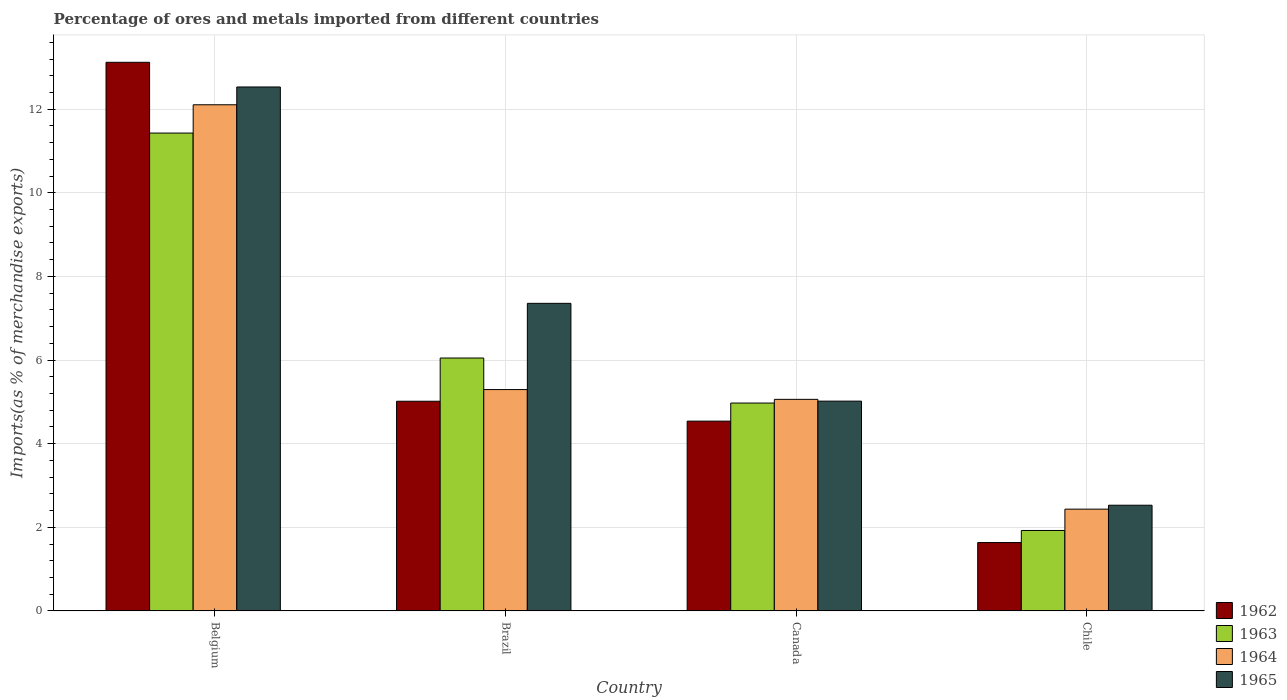How many different coloured bars are there?
Ensure brevity in your answer.  4. How many groups of bars are there?
Provide a succinct answer. 4. Are the number of bars per tick equal to the number of legend labels?
Your response must be concise. Yes. How many bars are there on the 2nd tick from the left?
Offer a very short reply. 4. How many bars are there on the 4th tick from the right?
Offer a very short reply. 4. In how many cases, is the number of bars for a given country not equal to the number of legend labels?
Your answer should be compact. 0. What is the percentage of imports to different countries in 1965 in Brazil?
Provide a succinct answer. 7.36. Across all countries, what is the maximum percentage of imports to different countries in 1965?
Give a very brief answer. 12.53. Across all countries, what is the minimum percentage of imports to different countries in 1965?
Make the answer very short. 2.53. In which country was the percentage of imports to different countries in 1962 maximum?
Provide a succinct answer. Belgium. In which country was the percentage of imports to different countries in 1963 minimum?
Make the answer very short. Chile. What is the total percentage of imports to different countries in 1965 in the graph?
Offer a terse response. 27.43. What is the difference between the percentage of imports to different countries in 1964 in Canada and that in Chile?
Keep it short and to the point. 2.63. What is the difference between the percentage of imports to different countries in 1965 in Belgium and the percentage of imports to different countries in 1963 in Brazil?
Provide a short and direct response. 6.48. What is the average percentage of imports to different countries in 1964 per country?
Offer a very short reply. 6.22. What is the difference between the percentage of imports to different countries of/in 1963 and percentage of imports to different countries of/in 1962 in Chile?
Your answer should be compact. 0.29. What is the ratio of the percentage of imports to different countries in 1962 in Brazil to that in Canada?
Make the answer very short. 1.1. Is the percentage of imports to different countries in 1964 in Belgium less than that in Brazil?
Your answer should be very brief. No. What is the difference between the highest and the second highest percentage of imports to different countries in 1965?
Keep it short and to the point. 7.51. What is the difference between the highest and the lowest percentage of imports to different countries in 1964?
Your response must be concise. 9.67. What does the 4th bar from the left in Brazil represents?
Give a very brief answer. 1965. What does the 1st bar from the right in Brazil represents?
Ensure brevity in your answer.  1965. How many bars are there?
Offer a terse response. 16. Are all the bars in the graph horizontal?
Provide a succinct answer. No. How many countries are there in the graph?
Give a very brief answer. 4. Does the graph contain grids?
Provide a short and direct response. Yes. What is the title of the graph?
Give a very brief answer. Percentage of ores and metals imported from different countries. What is the label or title of the X-axis?
Offer a very short reply. Country. What is the label or title of the Y-axis?
Provide a short and direct response. Imports(as % of merchandise exports). What is the Imports(as % of merchandise exports) of 1962 in Belgium?
Ensure brevity in your answer.  13.12. What is the Imports(as % of merchandise exports) in 1963 in Belgium?
Your answer should be very brief. 11.43. What is the Imports(as % of merchandise exports) in 1964 in Belgium?
Your response must be concise. 12.11. What is the Imports(as % of merchandise exports) of 1965 in Belgium?
Provide a succinct answer. 12.53. What is the Imports(as % of merchandise exports) of 1962 in Brazil?
Keep it short and to the point. 5.01. What is the Imports(as % of merchandise exports) in 1963 in Brazil?
Your response must be concise. 6.05. What is the Imports(as % of merchandise exports) in 1964 in Brazil?
Make the answer very short. 5.29. What is the Imports(as % of merchandise exports) of 1965 in Brazil?
Ensure brevity in your answer.  7.36. What is the Imports(as % of merchandise exports) of 1962 in Canada?
Ensure brevity in your answer.  4.54. What is the Imports(as % of merchandise exports) in 1963 in Canada?
Make the answer very short. 4.97. What is the Imports(as % of merchandise exports) of 1964 in Canada?
Give a very brief answer. 5.06. What is the Imports(as % of merchandise exports) of 1965 in Canada?
Make the answer very short. 5.02. What is the Imports(as % of merchandise exports) of 1962 in Chile?
Offer a very short reply. 1.63. What is the Imports(as % of merchandise exports) in 1963 in Chile?
Give a very brief answer. 1.92. What is the Imports(as % of merchandise exports) in 1964 in Chile?
Your response must be concise. 2.43. What is the Imports(as % of merchandise exports) of 1965 in Chile?
Give a very brief answer. 2.53. Across all countries, what is the maximum Imports(as % of merchandise exports) in 1962?
Your answer should be very brief. 13.12. Across all countries, what is the maximum Imports(as % of merchandise exports) in 1963?
Offer a very short reply. 11.43. Across all countries, what is the maximum Imports(as % of merchandise exports) in 1964?
Give a very brief answer. 12.11. Across all countries, what is the maximum Imports(as % of merchandise exports) of 1965?
Ensure brevity in your answer.  12.53. Across all countries, what is the minimum Imports(as % of merchandise exports) of 1962?
Your answer should be very brief. 1.63. Across all countries, what is the minimum Imports(as % of merchandise exports) in 1963?
Make the answer very short. 1.92. Across all countries, what is the minimum Imports(as % of merchandise exports) of 1964?
Ensure brevity in your answer.  2.43. Across all countries, what is the minimum Imports(as % of merchandise exports) of 1965?
Ensure brevity in your answer.  2.53. What is the total Imports(as % of merchandise exports) in 1962 in the graph?
Your answer should be compact. 24.31. What is the total Imports(as % of merchandise exports) of 1963 in the graph?
Give a very brief answer. 24.37. What is the total Imports(as % of merchandise exports) in 1964 in the graph?
Your answer should be very brief. 24.89. What is the total Imports(as % of merchandise exports) of 1965 in the graph?
Ensure brevity in your answer.  27.43. What is the difference between the Imports(as % of merchandise exports) in 1962 in Belgium and that in Brazil?
Give a very brief answer. 8.11. What is the difference between the Imports(as % of merchandise exports) of 1963 in Belgium and that in Brazil?
Provide a short and direct response. 5.38. What is the difference between the Imports(as % of merchandise exports) of 1964 in Belgium and that in Brazil?
Offer a terse response. 6.81. What is the difference between the Imports(as % of merchandise exports) of 1965 in Belgium and that in Brazil?
Your answer should be compact. 5.18. What is the difference between the Imports(as % of merchandise exports) in 1962 in Belgium and that in Canada?
Provide a succinct answer. 8.58. What is the difference between the Imports(as % of merchandise exports) in 1963 in Belgium and that in Canada?
Your answer should be very brief. 6.46. What is the difference between the Imports(as % of merchandise exports) in 1964 in Belgium and that in Canada?
Your answer should be very brief. 7.05. What is the difference between the Imports(as % of merchandise exports) of 1965 in Belgium and that in Canada?
Ensure brevity in your answer.  7.51. What is the difference between the Imports(as % of merchandise exports) in 1962 in Belgium and that in Chile?
Ensure brevity in your answer.  11.49. What is the difference between the Imports(as % of merchandise exports) of 1963 in Belgium and that in Chile?
Your response must be concise. 9.51. What is the difference between the Imports(as % of merchandise exports) of 1964 in Belgium and that in Chile?
Your response must be concise. 9.67. What is the difference between the Imports(as % of merchandise exports) in 1965 in Belgium and that in Chile?
Your answer should be very brief. 10. What is the difference between the Imports(as % of merchandise exports) in 1962 in Brazil and that in Canada?
Ensure brevity in your answer.  0.48. What is the difference between the Imports(as % of merchandise exports) of 1963 in Brazil and that in Canada?
Provide a succinct answer. 1.08. What is the difference between the Imports(as % of merchandise exports) of 1964 in Brazil and that in Canada?
Your answer should be compact. 0.23. What is the difference between the Imports(as % of merchandise exports) of 1965 in Brazil and that in Canada?
Offer a terse response. 2.34. What is the difference between the Imports(as % of merchandise exports) in 1962 in Brazil and that in Chile?
Ensure brevity in your answer.  3.38. What is the difference between the Imports(as % of merchandise exports) in 1963 in Brazil and that in Chile?
Your answer should be compact. 4.12. What is the difference between the Imports(as % of merchandise exports) of 1964 in Brazil and that in Chile?
Make the answer very short. 2.86. What is the difference between the Imports(as % of merchandise exports) of 1965 in Brazil and that in Chile?
Ensure brevity in your answer.  4.83. What is the difference between the Imports(as % of merchandise exports) of 1962 in Canada and that in Chile?
Keep it short and to the point. 2.9. What is the difference between the Imports(as % of merchandise exports) of 1963 in Canada and that in Chile?
Your answer should be compact. 3.05. What is the difference between the Imports(as % of merchandise exports) of 1964 in Canada and that in Chile?
Give a very brief answer. 2.63. What is the difference between the Imports(as % of merchandise exports) of 1965 in Canada and that in Chile?
Keep it short and to the point. 2.49. What is the difference between the Imports(as % of merchandise exports) of 1962 in Belgium and the Imports(as % of merchandise exports) of 1963 in Brazil?
Provide a short and direct response. 7.07. What is the difference between the Imports(as % of merchandise exports) in 1962 in Belgium and the Imports(as % of merchandise exports) in 1964 in Brazil?
Provide a succinct answer. 7.83. What is the difference between the Imports(as % of merchandise exports) in 1962 in Belgium and the Imports(as % of merchandise exports) in 1965 in Brazil?
Ensure brevity in your answer.  5.77. What is the difference between the Imports(as % of merchandise exports) in 1963 in Belgium and the Imports(as % of merchandise exports) in 1964 in Brazil?
Provide a succinct answer. 6.14. What is the difference between the Imports(as % of merchandise exports) in 1963 in Belgium and the Imports(as % of merchandise exports) in 1965 in Brazil?
Make the answer very short. 4.07. What is the difference between the Imports(as % of merchandise exports) in 1964 in Belgium and the Imports(as % of merchandise exports) in 1965 in Brazil?
Make the answer very short. 4.75. What is the difference between the Imports(as % of merchandise exports) of 1962 in Belgium and the Imports(as % of merchandise exports) of 1963 in Canada?
Ensure brevity in your answer.  8.15. What is the difference between the Imports(as % of merchandise exports) in 1962 in Belgium and the Imports(as % of merchandise exports) in 1964 in Canada?
Your answer should be compact. 8.06. What is the difference between the Imports(as % of merchandise exports) of 1962 in Belgium and the Imports(as % of merchandise exports) of 1965 in Canada?
Provide a short and direct response. 8.1. What is the difference between the Imports(as % of merchandise exports) in 1963 in Belgium and the Imports(as % of merchandise exports) in 1964 in Canada?
Provide a short and direct response. 6.37. What is the difference between the Imports(as % of merchandise exports) of 1963 in Belgium and the Imports(as % of merchandise exports) of 1965 in Canada?
Offer a very short reply. 6.41. What is the difference between the Imports(as % of merchandise exports) of 1964 in Belgium and the Imports(as % of merchandise exports) of 1965 in Canada?
Your response must be concise. 7.09. What is the difference between the Imports(as % of merchandise exports) of 1962 in Belgium and the Imports(as % of merchandise exports) of 1963 in Chile?
Your answer should be very brief. 11.2. What is the difference between the Imports(as % of merchandise exports) in 1962 in Belgium and the Imports(as % of merchandise exports) in 1964 in Chile?
Provide a short and direct response. 10.69. What is the difference between the Imports(as % of merchandise exports) in 1962 in Belgium and the Imports(as % of merchandise exports) in 1965 in Chile?
Offer a very short reply. 10.59. What is the difference between the Imports(as % of merchandise exports) of 1963 in Belgium and the Imports(as % of merchandise exports) of 1964 in Chile?
Provide a short and direct response. 9. What is the difference between the Imports(as % of merchandise exports) of 1963 in Belgium and the Imports(as % of merchandise exports) of 1965 in Chile?
Your response must be concise. 8.9. What is the difference between the Imports(as % of merchandise exports) in 1964 in Belgium and the Imports(as % of merchandise exports) in 1965 in Chile?
Offer a very short reply. 9.58. What is the difference between the Imports(as % of merchandise exports) of 1962 in Brazil and the Imports(as % of merchandise exports) of 1963 in Canada?
Give a very brief answer. 0.04. What is the difference between the Imports(as % of merchandise exports) of 1962 in Brazil and the Imports(as % of merchandise exports) of 1964 in Canada?
Provide a short and direct response. -0.05. What is the difference between the Imports(as % of merchandise exports) in 1962 in Brazil and the Imports(as % of merchandise exports) in 1965 in Canada?
Make the answer very short. -0. What is the difference between the Imports(as % of merchandise exports) of 1963 in Brazil and the Imports(as % of merchandise exports) of 1965 in Canada?
Your answer should be compact. 1.03. What is the difference between the Imports(as % of merchandise exports) of 1964 in Brazil and the Imports(as % of merchandise exports) of 1965 in Canada?
Your answer should be compact. 0.28. What is the difference between the Imports(as % of merchandise exports) in 1962 in Brazil and the Imports(as % of merchandise exports) in 1963 in Chile?
Ensure brevity in your answer.  3.09. What is the difference between the Imports(as % of merchandise exports) of 1962 in Brazil and the Imports(as % of merchandise exports) of 1964 in Chile?
Make the answer very short. 2.58. What is the difference between the Imports(as % of merchandise exports) in 1962 in Brazil and the Imports(as % of merchandise exports) in 1965 in Chile?
Provide a succinct answer. 2.49. What is the difference between the Imports(as % of merchandise exports) of 1963 in Brazil and the Imports(as % of merchandise exports) of 1964 in Chile?
Give a very brief answer. 3.61. What is the difference between the Imports(as % of merchandise exports) in 1963 in Brazil and the Imports(as % of merchandise exports) in 1965 in Chile?
Your answer should be very brief. 3.52. What is the difference between the Imports(as % of merchandise exports) in 1964 in Brazil and the Imports(as % of merchandise exports) in 1965 in Chile?
Make the answer very short. 2.77. What is the difference between the Imports(as % of merchandise exports) of 1962 in Canada and the Imports(as % of merchandise exports) of 1963 in Chile?
Provide a succinct answer. 2.62. What is the difference between the Imports(as % of merchandise exports) in 1962 in Canada and the Imports(as % of merchandise exports) in 1964 in Chile?
Offer a terse response. 2.11. What is the difference between the Imports(as % of merchandise exports) in 1962 in Canada and the Imports(as % of merchandise exports) in 1965 in Chile?
Provide a short and direct response. 2.01. What is the difference between the Imports(as % of merchandise exports) in 1963 in Canada and the Imports(as % of merchandise exports) in 1964 in Chile?
Provide a succinct answer. 2.54. What is the difference between the Imports(as % of merchandise exports) of 1963 in Canada and the Imports(as % of merchandise exports) of 1965 in Chile?
Offer a very short reply. 2.44. What is the difference between the Imports(as % of merchandise exports) of 1964 in Canada and the Imports(as % of merchandise exports) of 1965 in Chile?
Your response must be concise. 2.53. What is the average Imports(as % of merchandise exports) of 1962 per country?
Provide a succinct answer. 6.08. What is the average Imports(as % of merchandise exports) in 1963 per country?
Give a very brief answer. 6.09. What is the average Imports(as % of merchandise exports) of 1964 per country?
Make the answer very short. 6.22. What is the average Imports(as % of merchandise exports) of 1965 per country?
Give a very brief answer. 6.86. What is the difference between the Imports(as % of merchandise exports) of 1962 and Imports(as % of merchandise exports) of 1963 in Belgium?
Your response must be concise. 1.69. What is the difference between the Imports(as % of merchandise exports) in 1962 and Imports(as % of merchandise exports) in 1965 in Belgium?
Provide a short and direct response. 0.59. What is the difference between the Imports(as % of merchandise exports) of 1963 and Imports(as % of merchandise exports) of 1964 in Belgium?
Your answer should be very brief. -0.68. What is the difference between the Imports(as % of merchandise exports) of 1963 and Imports(as % of merchandise exports) of 1965 in Belgium?
Make the answer very short. -1.1. What is the difference between the Imports(as % of merchandise exports) in 1964 and Imports(as % of merchandise exports) in 1965 in Belgium?
Provide a succinct answer. -0.43. What is the difference between the Imports(as % of merchandise exports) in 1962 and Imports(as % of merchandise exports) in 1963 in Brazil?
Keep it short and to the point. -1.03. What is the difference between the Imports(as % of merchandise exports) of 1962 and Imports(as % of merchandise exports) of 1964 in Brazil?
Your response must be concise. -0.28. What is the difference between the Imports(as % of merchandise exports) of 1962 and Imports(as % of merchandise exports) of 1965 in Brazil?
Make the answer very short. -2.34. What is the difference between the Imports(as % of merchandise exports) in 1963 and Imports(as % of merchandise exports) in 1964 in Brazil?
Your answer should be very brief. 0.75. What is the difference between the Imports(as % of merchandise exports) of 1963 and Imports(as % of merchandise exports) of 1965 in Brazil?
Your answer should be very brief. -1.31. What is the difference between the Imports(as % of merchandise exports) in 1964 and Imports(as % of merchandise exports) in 1965 in Brazil?
Provide a succinct answer. -2.06. What is the difference between the Imports(as % of merchandise exports) of 1962 and Imports(as % of merchandise exports) of 1963 in Canada?
Offer a terse response. -0.43. What is the difference between the Imports(as % of merchandise exports) of 1962 and Imports(as % of merchandise exports) of 1964 in Canada?
Give a very brief answer. -0.52. What is the difference between the Imports(as % of merchandise exports) in 1962 and Imports(as % of merchandise exports) in 1965 in Canada?
Give a very brief answer. -0.48. What is the difference between the Imports(as % of merchandise exports) in 1963 and Imports(as % of merchandise exports) in 1964 in Canada?
Ensure brevity in your answer.  -0.09. What is the difference between the Imports(as % of merchandise exports) in 1963 and Imports(as % of merchandise exports) in 1965 in Canada?
Provide a succinct answer. -0.05. What is the difference between the Imports(as % of merchandise exports) of 1964 and Imports(as % of merchandise exports) of 1965 in Canada?
Make the answer very short. 0.04. What is the difference between the Imports(as % of merchandise exports) in 1962 and Imports(as % of merchandise exports) in 1963 in Chile?
Offer a terse response. -0.29. What is the difference between the Imports(as % of merchandise exports) in 1962 and Imports(as % of merchandise exports) in 1964 in Chile?
Provide a short and direct response. -0.8. What is the difference between the Imports(as % of merchandise exports) of 1962 and Imports(as % of merchandise exports) of 1965 in Chile?
Ensure brevity in your answer.  -0.89. What is the difference between the Imports(as % of merchandise exports) of 1963 and Imports(as % of merchandise exports) of 1964 in Chile?
Make the answer very short. -0.51. What is the difference between the Imports(as % of merchandise exports) in 1963 and Imports(as % of merchandise exports) in 1965 in Chile?
Provide a succinct answer. -0.6. What is the difference between the Imports(as % of merchandise exports) in 1964 and Imports(as % of merchandise exports) in 1965 in Chile?
Your response must be concise. -0.09. What is the ratio of the Imports(as % of merchandise exports) in 1962 in Belgium to that in Brazil?
Keep it short and to the point. 2.62. What is the ratio of the Imports(as % of merchandise exports) of 1963 in Belgium to that in Brazil?
Offer a very short reply. 1.89. What is the ratio of the Imports(as % of merchandise exports) of 1964 in Belgium to that in Brazil?
Your response must be concise. 2.29. What is the ratio of the Imports(as % of merchandise exports) in 1965 in Belgium to that in Brazil?
Your answer should be very brief. 1.7. What is the ratio of the Imports(as % of merchandise exports) in 1962 in Belgium to that in Canada?
Give a very brief answer. 2.89. What is the ratio of the Imports(as % of merchandise exports) of 1963 in Belgium to that in Canada?
Your answer should be compact. 2.3. What is the ratio of the Imports(as % of merchandise exports) in 1964 in Belgium to that in Canada?
Ensure brevity in your answer.  2.39. What is the ratio of the Imports(as % of merchandise exports) of 1965 in Belgium to that in Canada?
Offer a terse response. 2.5. What is the ratio of the Imports(as % of merchandise exports) of 1962 in Belgium to that in Chile?
Offer a terse response. 8.03. What is the ratio of the Imports(as % of merchandise exports) in 1963 in Belgium to that in Chile?
Provide a succinct answer. 5.94. What is the ratio of the Imports(as % of merchandise exports) of 1964 in Belgium to that in Chile?
Your answer should be compact. 4.97. What is the ratio of the Imports(as % of merchandise exports) of 1965 in Belgium to that in Chile?
Provide a succinct answer. 4.96. What is the ratio of the Imports(as % of merchandise exports) in 1962 in Brazil to that in Canada?
Give a very brief answer. 1.1. What is the ratio of the Imports(as % of merchandise exports) of 1963 in Brazil to that in Canada?
Offer a very short reply. 1.22. What is the ratio of the Imports(as % of merchandise exports) of 1964 in Brazil to that in Canada?
Ensure brevity in your answer.  1.05. What is the ratio of the Imports(as % of merchandise exports) of 1965 in Brazil to that in Canada?
Offer a terse response. 1.47. What is the ratio of the Imports(as % of merchandise exports) in 1962 in Brazil to that in Chile?
Offer a terse response. 3.07. What is the ratio of the Imports(as % of merchandise exports) of 1963 in Brazil to that in Chile?
Ensure brevity in your answer.  3.14. What is the ratio of the Imports(as % of merchandise exports) in 1964 in Brazil to that in Chile?
Offer a very short reply. 2.18. What is the ratio of the Imports(as % of merchandise exports) of 1965 in Brazil to that in Chile?
Your response must be concise. 2.91. What is the ratio of the Imports(as % of merchandise exports) of 1962 in Canada to that in Chile?
Provide a succinct answer. 2.78. What is the ratio of the Imports(as % of merchandise exports) in 1963 in Canada to that in Chile?
Give a very brief answer. 2.58. What is the ratio of the Imports(as % of merchandise exports) in 1964 in Canada to that in Chile?
Ensure brevity in your answer.  2.08. What is the ratio of the Imports(as % of merchandise exports) of 1965 in Canada to that in Chile?
Give a very brief answer. 1.99. What is the difference between the highest and the second highest Imports(as % of merchandise exports) in 1962?
Offer a terse response. 8.11. What is the difference between the highest and the second highest Imports(as % of merchandise exports) in 1963?
Provide a short and direct response. 5.38. What is the difference between the highest and the second highest Imports(as % of merchandise exports) in 1964?
Provide a succinct answer. 6.81. What is the difference between the highest and the second highest Imports(as % of merchandise exports) of 1965?
Offer a terse response. 5.18. What is the difference between the highest and the lowest Imports(as % of merchandise exports) in 1962?
Your answer should be very brief. 11.49. What is the difference between the highest and the lowest Imports(as % of merchandise exports) in 1963?
Offer a terse response. 9.51. What is the difference between the highest and the lowest Imports(as % of merchandise exports) of 1964?
Your answer should be very brief. 9.67. What is the difference between the highest and the lowest Imports(as % of merchandise exports) in 1965?
Your answer should be compact. 10. 